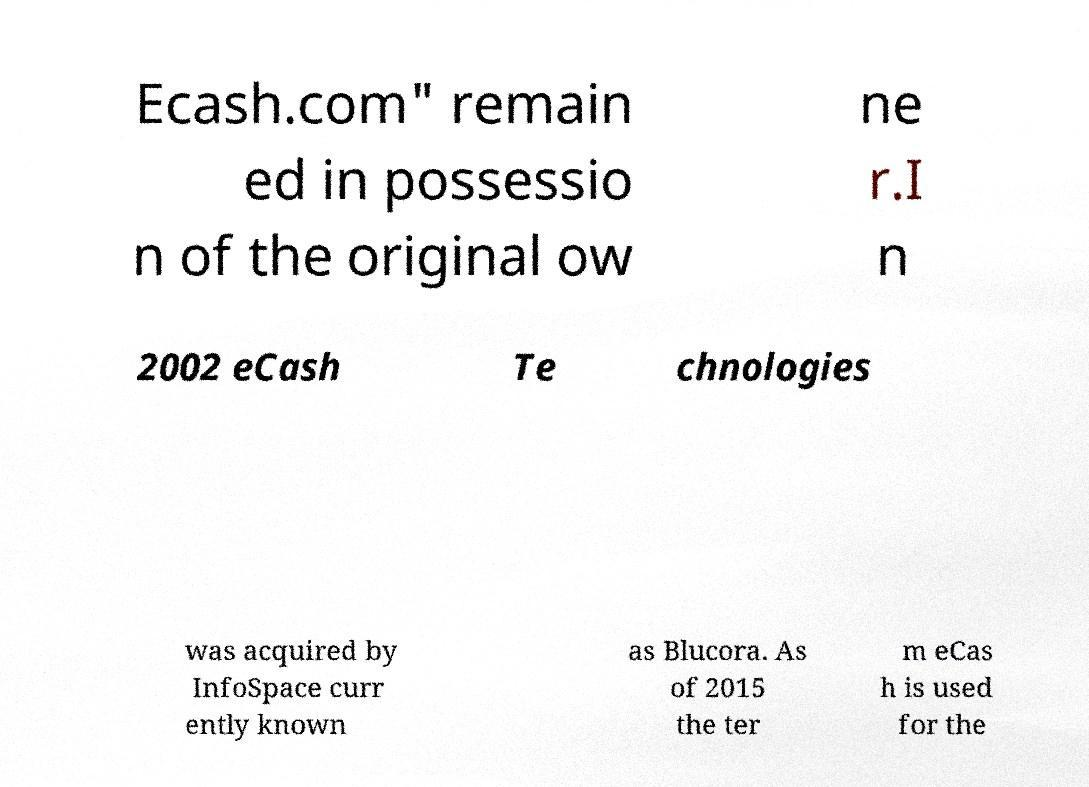Can you accurately transcribe the text from the provided image for me? Ecash.com" remain ed in possessio n of the original ow ne r.I n 2002 eCash Te chnologies was acquired by InfoSpace curr ently known as Blucora. As of 2015 the ter m eCas h is used for the 